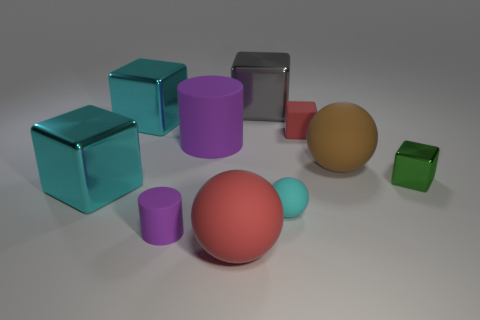Subtract all big rubber balls. How many balls are left? 1 Subtract all green blocks. How many blocks are left? 4 Subtract 1 spheres. How many spheres are left? 2 Subtract all cylinders. How many objects are left? 8 Subtract all green spheres. Subtract all gray cylinders. How many spheres are left? 3 Subtract all purple cylinders. How many blue spheres are left? 0 Subtract all large gray cubes. Subtract all green blocks. How many objects are left? 8 Add 9 small purple objects. How many small purple objects are left? 10 Add 2 small green blocks. How many small green blocks exist? 3 Subtract 1 gray blocks. How many objects are left? 9 